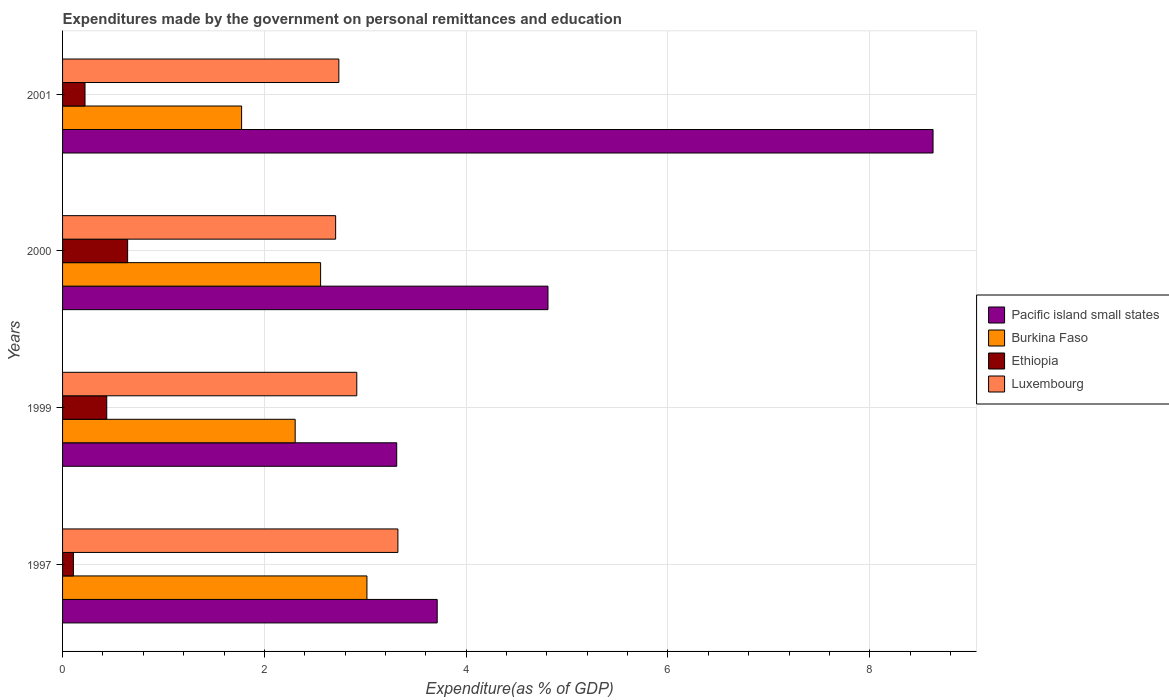How many bars are there on the 2nd tick from the top?
Your answer should be compact. 4. How many bars are there on the 1st tick from the bottom?
Ensure brevity in your answer.  4. In how many cases, is the number of bars for a given year not equal to the number of legend labels?
Your answer should be very brief. 0. What is the expenditures made by the government on personal remittances and education in Ethiopia in 2001?
Provide a short and direct response. 0.22. Across all years, what is the maximum expenditures made by the government on personal remittances and education in Burkina Faso?
Ensure brevity in your answer.  3.02. Across all years, what is the minimum expenditures made by the government on personal remittances and education in Pacific island small states?
Offer a very short reply. 3.31. What is the total expenditures made by the government on personal remittances and education in Luxembourg in the graph?
Your answer should be compact. 11.68. What is the difference between the expenditures made by the government on personal remittances and education in Pacific island small states in 1997 and that in 1999?
Provide a succinct answer. 0.4. What is the difference between the expenditures made by the government on personal remittances and education in Ethiopia in 1999 and the expenditures made by the government on personal remittances and education in Pacific island small states in 2001?
Give a very brief answer. -8.19. What is the average expenditures made by the government on personal remittances and education in Ethiopia per year?
Ensure brevity in your answer.  0.35. In the year 2000, what is the difference between the expenditures made by the government on personal remittances and education in Burkina Faso and expenditures made by the government on personal remittances and education in Luxembourg?
Your answer should be very brief. -0.15. What is the ratio of the expenditures made by the government on personal remittances and education in Burkina Faso in 1997 to that in 2000?
Keep it short and to the point. 1.18. What is the difference between the highest and the second highest expenditures made by the government on personal remittances and education in Pacific island small states?
Give a very brief answer. 3.82. What is the difference between the highest and the lowest expenditures made by the government on personal remittances and education in Burkina Faso?
Provide a short and direct response. 1.24. Is the sum of the expenditures made by the government on personal remittances and education in Luxembourg in 1997 and 1999 greater than the maximum expenditures made by the government on personal remittances and education in Burkina Faso across all years?
Make the answer very short. Yes. What does the 4th bar from the top in 1997 represents?
Offer a very short reply. Pacific island small states. What does the 4th bar from the bottom in 1999 represents?
Your answer should be compact. Luxembourg. How many bars are there?
Your answer should be compact. 16. Are all the bars in the graph horizontal?
Provide a short and direct response. Yes. How many years are there in the graph?
Offer a very short reply. 4. Where does the legend appear in the graph?
Offer a terse response. Center right. How many legend labels are there?
Provide a succinct answer. 4. What is the title of the graph?
Your response must be concise. Expenditures made by the government on personal remittances and education. What is the label or title of the X-axis?
Ensure brevity in your answer.  Expenditure(as % of GDP). What is the label or title of the Y-axis?
Keep it short and to the point. Years. What is the Expenditure(as % of GDP) in Pacific island small states in 1997?
Ensure brevity in your answer.  3.71. What is the Expenditure(as % of GDP) in Burkina Faso in 1997?
Keep it short and to the point. 3.02. What is the Expenditure(as % of GDP) in Ethiopia in 1997?
Your answer should be compact. 0.11. What is the Expenditure(as % of GDP) of Luxembourg in 1997?
Give a very brief answer. 3.32. What is the Expenditure(as % of GDP) in Pacific island small states in 1999?
Your answer should be very brief. 3.31. What is the Expenditure(as % of GDP) in Burkina Faso in 1999?
Make the answer very short. 2.31. What is the Expenditure(as % of GDP) in Ethiopia in 1999?
Your answer should be compact. 0.44. What is the Expenditure(as % of GDP) of Luxembourg in 1999?
Ensure brevity in your answer.  2.92. What is the Expenditure(as % of GDP) of Pacific island small states in 2000?
Offer a very short reply. 4.81. What is the Expenditure(as % of GDP) of Burkina Faso in 2000?
Your answer should be very brief. 2.56. What is the Expenditure(as % of GDP) of Ethiopia in 2000?
Give a very brief answer. 0.64. What is the Expenditure(as % of GDP) of Luxembourg in 2000?
Offer a very short reply. 2.71. What is the Expenditure(as % of GDP) in Pacific island small states in 2001?
Ensure brevity in your answer.  8.63. What is the Expenditure(as % of GDP) of Burkina Faso in 2001?
Make the answer very short. 1.77. What is the Expenditure(as % of GDP) of Ethiopia in 2001?
Your response must be concise. 0.22. What is the Expenditure(as % of GDP) of Luxembourg in 2001?
Provide a short and direct response. 2.74. Across all years, what is the maximum Expenditure(as % of GDP) of Pacific island small states?
Your answer should be compact. 8.63. Across all years, what is the maximum Expenditure(as % of GDP) in Burkina Faso?
Provide a short and direct response. 3.02. Across all years, what is the maximum Expenditure(as % of GDP) of Ethiopia?
Your answer should be compact. 0.64. Across all years, what is the maximum Expenditure(as % of GDP) of Luxembourg?
Provide a short and direct response. 3.32. Across all years, what is the minimum Expenditure(as % of GDP) of Pacific island small states?
Provide a succinct answer. 3.31. Across all years, what is the minimum Expenditure(as % of GDP) in Burkina Faso?
Ensure brevity in your answer.  1.77. Across all years, what is the minimum Expenditure(as % of GDP) in Ethiopia?
Your answer should be very brief. 0.11. Across all years, what is the minimum Expenditure(as % of GDP) in Luxembourg?
Offer a terse response. 2.71. What is the total Expenditure(as % of GDP) of Pacific island small states in the graph?
Provide a short and direct response. 20.46. What is the total Expenditure(as % of GDP) in Burkina Faso in the graph?
Provide a succinct answer. 9.65. What is the total Expenditure(as % of GDP) in Ethiopia in the graph?
Keep it short and to the point. 1.41. What is the total Expenditure(as % of GDP) of Luxembourg in the graph?
Keep it short and to the point. 11.68. What is the difference between the Expenditure(as % of GDP) in Pacific island small states in 1997 and that in 1999?
Offer a very short reply. 0.4. What is the difference between the Expenditure(as % of GDP) in Burkina Faso in 1997 and that in 1999?
Your answer should be very brief. 0.71. What is the difference between the Expenditure(as % of GDP) in Ethiopia in 1997 and that in 1999?
Give a very brief answer. -0.33. What is the difference between the Expenditure(as % of GDP) in Luxembourg in 1997 and that in 1999?
Offer a very short reply. 0.41. What is the difference between the Expenditure(as % of GDP) in Pacific island small states in 1997 and that in 2000?
Ensure brevity in your answer.  -1.1. What is the difference between the Expenditure(as % of GDP) in Burkina Faso in 1997 and that in 2000?
Offer a very short reply. 0.46. What is the difference between the Expenditure(as % of GDP) in Ethiopia in 1997 and that in 2000?
Provide a short and direct response. -0.54. What is the difference between the Expenditure(as % of GDP) of Luxembourg in 1997 and that in 2000?
Keep it short and to the point. 0.62. What is the difference between the Expenditure(as % of GDP) of Pacific island small states in 1997 and that in 2001?
Your response must be concise. -4.91. What is the difference between the Expenditure(as % of GDP) of Burkina Faso in 1997 and that in 2001?
Your answer should be very brief. 1.24. What is the difference between the Expenditure(as % of GDP) in Ethiopia in 1997 and that in 2001?
Your answer should be very brief. -0.12. What is the difference between the Expenditure(as % of GDP) in Luxembourg in 1997 and that in 2001?
Ensure brevity in your answer.  0.59. What is the difference between the Expenditure(as % of GDP) of Pacific island small states in 1999 and that in 2000?
Offer a very short reply. -1.5. What is the difference between the Expenditure(as % of GDP) of Burkina Faso in 1999 and that in 2000?
Your response must be concise. -0.25. What is the difference between the Expenditure(as % of GDP) in Ethiopia in 1999 and that in 2000?
Ensure brevity in your answer.  -0.21. What is the difference between the Expenditure(as % of GDP) of Luxembourg in 1999 and that in 2000?
Your response must be concise. 0.21. What is the difference between the Expenditure(as % of GDP) of Pacific island small states in 1999 and that in 2001?
Offer a terse response. -5.32. What is the difference between the Expenditure(as % of GDP) in Burkina Faso in 1999 and that in 2001?
Make the answer very short. 0.53. What is the difference between the Expenditure(as % of GDP) in Ethiopia in 1999 and that in 2001?
Ensure brevity in your answer.  0.22. What is the difference between the Expenditure(as % of GDP) of Luxembourg in 1999 and that in 2001?
Your response must be concise. 0.18. What is the difference between the Expenditure(as % of GDP) in Pacific island small states in 2000 and that in 2001?
Provide a succinct answer. -3.82. What is the difference between the Expenditure(as % of GDP) of Burkina Faso in 2000 and that in 2001?
Your answer should be compact. 0.78. What is the difference between the Expenditure(as % of GDP) of Ethiopia in 2000 and that in 2001?
Provide a short and direct response. 0.42. What is the difference between the Expenditure(as % of GDP) in Luxembourg in 2000 and that in 2001?
Your response must be concise. -0.03. What is the difference between the Expenditure(as % of GDP) of Pacific island small states in 1997 and the Expenditure(as % of GDP) of Burkina Faso in 1999?
Keep it short and to the point. 1.41. What is the difference between the Expenditure(as % of GDP) of Pacific island small states in 1997 and the Expenditure(as % of GDP) of Ethiopia in 1999?
Provide a succinct answer. 3.28. What is the difference between the Expenditure(as % of GDP) of Pacific island small states in 1997 and the Expenditure(as % of GDP) of Luxembourg in 1999?
Keep it short and to the point. 0.8. What is the difference between the Expenditure(as % of GDP) in Burkina Faso in 1997 and the Expenditure(as % of GDP) in Ethiopia in 1999?
Keep it short and to the point. 2.58. What is the difference between the Expenditure(as % of GDP) in Burkina Faso in 1997 and the Expenditure(as % of GDP) in Luxembourg in 1999?
Give a very brief answer. 0.1. What is the difference between the Expenditure(as % of GDP) of Ethiopia in 1997 and the Expenditure(as % of GDP) of Luxembourg in 1999?
Your answer should be very brief. -2.81. What is the difference between the Expenditure(as % of GDP) in Pacific island small states in 1997 and the Expenditure(as % of GDP) in Burkina Faso in 2000?
Make the answer very short. 1.16. What is the difference between the Expenditure(as % of GDP) in Pacific island small states in 1997 and the Expenditure(as % of GDP) in Ethiopia in 2000?
Your response must be concise. 3.07. What is the difference between the Expenditure(as % of GDP) in Pacific island small states in 1997 and the Expenditure(as % of GDP) in Luxembourg in 2000?
Keep it short and to the point. 1.01. What is the difference between the Expenditure(as % of GDP) in Burkina Faso in 1997 and the Expenditure(as % of GDP) in Ethiopia in 2000?
Provide a succinct answer. 2.37. What is the difference between the Expenditure(as % of GDP) in Burkina Faso in 1997 and the Expenditure(as % of GDP) in Luxembourg in 2000?
Your answer should be compact. 0.31. What is the difference between the Expenditure(as % of GDP) of Ethiopia in 1997 and the Expenditure(as % of GDP) of Luxembourg in 2000?
Ensure brevity in your answer.  -2.6. What is the difference between the Expenditure(as % of GDP) of Pacific island small states in 1997 and the Expenditure(as % of GDP) of Burkina Faso in 2001?
Your response must be concise. 1.94. What is the difference between the Expenditure(as % of GDP) of Pacific island small states in 1997 and the Expenditure(as % of GDP) of Ethiopia in 2001?
Give a very brief answer. 3.49. What is the difference between the Expenditure(as % of GDP) of Pacific island small states in 1997 and the Expenditure(as % of GDP) of Luxembourg in 2001?
Keep it short and to the point. 0.97. What is the difference between the Expenditure(as % of GDP) in Burkina Faso in 1997 and the Expenditure(as % of GDP) in Ethiopia in 2001?
Your answer should be very brief. 2.79. What is the difference between the Expenditure(as % of GDP) of Burkina Faso in 1997 and the Expenditure(as % of GDP) of Luxembourg in 2001?
Provide a short and direct response. 0.28. What is the difference between the Expenditure(as % of GDP) of Ethiopia in 1997 and the Expenditure(as % of GDP) of Luxembourg in 2001?
Offer a very short reply. -2.63. What is the difference between the Expenditure(as % of GDP) of Pacific island small states in 1999 and the Expenditure(as % of GDP) of Burkina Faso in 2000?
Provide a short and direct response. 0.75. What is the difference between the Expenditure(as % of GDP) of Pacific island small states in 1999 and the Expenditure(as % of GDP) of Ethiopia in 2000?
Offer a very short reply. 2.67. What is the difference between the Expenditure(as % of GDP) in Pacific island small states in 1999 and the Expenditure(as % of GDP) in Luxembourg in 2000?
Ensure brevity in your answer.  0.61. What is the difference between the Expenditure(as % of GDP) in Burkina Faso in 1999 and the Expenditure(as % of GDP) in Ethiopia in 2000?
Provide a succinct answer. 1.66. What is the difference between the Expenditure(as % of GDP) in Burkina Faso in 1999 and the Expenditure(as % of GDP) in Luxembourg in 2000?
Keep it short and to the point. -0.4. What is the difference between the Expenditure(as % of GDP) of Ethiopia in 1999 and the Expenditure(as % of GDP) of Luxembourg in 2000?
Keep it short and to the point. -2.27. What is the difference between the Expenditure(as % of GDP) of Pacific island small states in 1999 and the Expenditure(as % of GDP) of Burkina Faso in 2001?
Your response must be concise. 1.54. What is the difference between the Expenditure(as % of GDP) in Pacific island small states in 1999 and the Expenditure(as % of GDP) in Ethiopia in 2001?
Offer a terse response. 3.09. What is the difference between the Expenditure(as % of GDP) in Pacific island small states in 1999 and the Expenditure(as % of GDP) in Luxembourg in 2001?
Provide a succinct answer. 0.57. What is the difference between the Expenditure(as % of GDP) in Burkina Faso in 1999 and the Expenditure(as % of GDP) in Ethiopia in 2001?
Offer a very short reply. 2.08. What is the difference between the Expenditure(as % of GDP) in Burkina Faso in 1999 and the Expenditure(as % of GDP) in Luxembourg in 2001?
Provide a short and direct response. -0.43. What is the difference between the Expenditure(as % of GDP) of Ethiopia in 1999 and the Expenditure(as % of GDP) of Luxembourg in 2001?
Provide a succinct answer. -2.3. What is the difference between the Expenditure(as % of GDP) of Pacific island small states in 2000 and the Expenditure(as % of GDP) of Burkina Faso in 2001?
Your answer should be very brief. 3.04. What is the difference between the Expenditure(as % of GDP) of Pacific island small states in 2000 and the Expenditure(as % of GDP) of Ethiopia in 2001?
Your response must be concise. 4.59. What is the difference between the Expenditure(as % of GDP) in Pacific island small states in 2000 and the Expenditure(as % of GDP) in Luxembourg in 2001?
Your answer should be compact. 2.07. What is the difference between the Expenditure(as % of GDP) of Burkina Faso in 2000 and the Expenditure(as % of GDP) of Ethiopia in 2001?
Give a very brief answer. 2.34. What is the difference between the Expenditure(as % of GDP) of Burkina Faso in 2000 and the Expenditure(as % of GDP) of Luxembourg in 2001?
Make the answer very short. -0.18. What is the difference between the Expenditure(as % of GDP) of Ethiopia in 2000 and the Expenditure(as % of GDP) of Luxembourg in 2001?
Keep it short and to the point. -2.09. What is the average Expenditure(as % of GDP) in Pacific island small states per year?
Give a very brief answer. 5.12. What is the average Expenditure(as % of GDP) in Burkina Faso per year?
Keep it short and to the point. 2.41. What is the average Expenditure(as % of GDP) in Ethiopia per year?
Make the answer very short. 0.35. What is the average Expenditure(as % of GDP) in Luxembourg per year?
Keep it short and to the point. 2.92. In the year 1997, what is the difference between the Expenditure(as % of GDP) of Pacific island small states and Expenditure(as % of GDP) of Burkina Faso?
Provide a short and direct response. 0.7. In the year 1997, what is the difference between the Expenditure(as % of GDP) of Pacific island small states and Expenditure(as % of GDP) of Ethiopia?
Your answer should be very brief. 3.61. In the year 1997, what is the difference between the Expenditure(as % of GDP) in Pacific island small states and Expenditure(as % of GDP) in Luxembourg?
Give a very brief answer. 0.39. In the year 1997, what is the difference between the Expenditure(as % of GDP) of Burkina Faso and Expenditure(as % of GDP) of Ethiopia?
Your answer should be compact. 2.91. In the year 1997, what is the difference between the Expenditure(as % of GDP) of Burkina Faso and Expenditure(as % of GDP) of Luxembourg?
Offer a terse response. -0.31. In the year 1997, what is the difference between the Expenditure(as % of GDP) in Ethiopia and Expenditure(as % of GDP) in Luxembourg?
Keep it short and to the point. -3.22. In the year 1999, what is the difference between the Expenditure(as % of GDP) of Pacific island small states and Expenditure(as % of GDP) of Burkina Faso?
Give a very brief answer. 1.01. In the year 1999, what is the difference between the Expenditure(as % of GDP) in Pacific island small states and Expenditure(as % of GDP) in Ethiopia?
Ensure brevity in your answer.  2.87. In the year 1999, what is the difference between the Expenditure(as % of GDP) in Pacific island small states and Expenditure(as % of GDP) in Luxembourg?
Your answer should be compact. 0.4. In the year 1999, what is the difference between the Expenditure(as % of GDP) of Burkina Faso and Expenditure(as % of GDP) of Ethiopia?
Your answer should be very brief. 1.87. In the year 1999, what is the difference between the Expenditure(as % of GDP) of Burkina Faso and Expenditure(as % of GDP) of Luxembourg?
Your response must be concise. -0.61. In the year 1999, what is the difference between the Expenditure(as % of GDP) of Ethiopia and Expenditure(as % of GDP) of Luxembourg?
Give a very brief answer. -2.48. In the year 2000, what is the difference between the Expenditure(as % of GDP) of Pacific island small states and Expenditure(as % of GDP) of Burkina Faso?
Provide a short and direct response. 2.25. In the year 2000, what is the difference between the Expenditure(as % of GDP) in Pacific island small states and Expenditure(as % of GDP) in Ethiopia?
Give a very brief answer. 4.17. In the year 2000, what is the difference between the Expenditure(as % of GDP) in Pacific island small states and Expenditure(as % of GDP) in Luxembourg?
Offer a terse response. 2.1. In the year 2000, what is the difference between the Expenditure(as % of GDP) in Burkina Faso and Expenditure(as % of GDP) in Ethiopia?
Your answer should be very brief. 1.91. In the year 2000, what is the difference between the Expenditure(as % of GDP) in Burkina Faso and Expenditure(as % of GDP) in Luxembourg?
Provide a succinct answer. -0.15. In the year 2000, what is the difference between the Expenditure(as % of GDP) of Ethiopia and Expenditure(as % of GDP) of Luxembourg?
Your answer should be very brief. -2.06. In the year 2001, what is the difference between the Expenditure(as % of GDP) in Pacific island small states and Expenditure(as % of GDP) in Burkina Faso?
Offer a terse response. 6.85. In the year 2001, what is the difference between the Expenditure(as % of GDP) of Pacific island small states and Expenditure(as % of GDP) of Ethiopia?
Offer a very short reply. 8.41. In the year 2001, what is the difference between the Expenditure(as % of GDP) of Pacific island small states and Expenditure(as % of GDP) of Luxembourg?
Keep it short and to the point. 5.89. In the year 2001, what is the difference between the Expenditure(as % of GDP) of Burkina Faso and Expenditure(as % of GDP) of Ethiopia?
Give a very brief answer. 1.55. In the year 2001, what is the difference between the Expenditure(as % of GDP) of Burkina Faso and Expenditure(as % of GDP) of Luxembourg?
Keep it short and to the point. -0.96. In the year 2001, what is the difference between the Expenditure(as % of GDP) in Ethiopia and Expenditure(as % of GDP) in Luxembourg?
Offer a very short reply. -2.52. What is the ratio of the Expenditure(as % of GDP) of Pacific island small states in 1997 to that in 1999?
Ensure brevity in your answer.  1.12. What is the ratio of the Expenditure(as % of GDP) of Burkina Faso in 1997 to that in 1999?
Offer a very short reply. 1.31. What is the ratio of the Expenditure(as % of GDP) of Ethiopia in 1997 to that in 1999?
Keep it short and to the point. 0.25. What is the ratio of the Expenditure(as % of GDP) of Luxembourg in 1997 to that in 1999?
Offer a very short reply. 1.14. What is the ratio of the Expenditure(as % of GDP) of Pacific island small states in 1997 to that in 2000?
Keep it short and to the point. 0.77. What is the ratio of the Expenditure(as % of GDP) in Burkina Faso in 1997 to that in 2000?
Give a very brief answer. 1.18. What is the ratio of the Expenditure(as % of GDP) in Luxembourg in 1997 to that in 2000?
Make the answer very short. 1.23. What is the ratio of the Expenditure(as % of GDP) of Pacific island small states in 1997 to that in 2001?
Offer a terse response. 0.43. What is the ratio of the Expenditure(as % of GDP) in Ethiopia in 1997 to that in 2001?
Offer a terse response. 0.48. What is the ratio of the Expenditure(as % of GDP) of Luxembourg in 1997 to that in 2001?
Your answer should be very brief. 1.21. What is the ratio of the Expenditure(as % of GDP) of Pacific island small states in 1999 to that in 2000?
Keep it short and to the point. 0.69. What is the ratio of the Expenditure(as % of GDP) in Burkina Faso in 1999 to that in 2000?
Give a very brief answer. 0.9. What is the ratio of the Expenditure(as % of GDP) of Ethiopia in 1999 to that in 2000?
Keep it short and to the point. 0.68. What is the ratio of the Expenditure(as % of GDP) of Luxembourg in 1999 to that in 2000?
Ensure brevity in your answer.  1.08. What is the ratio of the Expenditure(as % of GDP) of Pacific island small states in 1999 to that in 2001?
Ensure brevity in your answer.  0.38. What is the ratio of the Expenditure(as % of GDP) of Burkina Faso in 1999 to that in 2001?
Your answer should be very brief. 1.3. What is the ratio of the Expenditure(as % of GDP) in Ethiopia in 1999 to that in 2001?
Offer a terse response. 1.97. What is the ratio of the Expenditure(as % of GDP) of Luxembourg in 1999 to that in 2001?
Give a very brief answer. 1.06. What is the ratio of the Expenditure(as % of GDP) of Pacific island small states in 2000 to that in 2001?
Your answer should be very brief. 0.56. What is the ratio of the Expenditure(as % of GDP) of Burkina Faso in 2000 to that in 2001?
Keep it short and to the point. 1.44. What is the ratio of the Expenditure(as % of GDP) of Ethiopia in 2000 to that in 2001?
Offer a terse response. 2.9. What is the ratio of the Expenditure(as % of GDP) in Luxembourg in 2000 to that in 2001?
Ensure brevity in your answer.  0.99. What is the difference between the highest and the second highest Expenditure(as % of GDP) in Pacific island small states?
Your answer should be compact. 3.82. What is the difference between the highest and the second highest Expenditure(as % of GDP) of Burkina Faso?
Offer a very short reply. 0.46. What is the difference between the highest and the second highest Expenditure(as % of GDP) of Ethiopia?
Provide a short and direct response. 0.21. What is the difference between the highest and the second highest Expenditure(as % of GDP) of Luxembourg?
Your answer should be very brief. 0.41. What is the difference between the highest and the lowest Expenditure(as % of GDP) in Pacific island small states?
Give a very brief answer. 5.32. What is the difference between the highest and the lowest Expenditure(as % of GDP) in Burkina Faso?
Ensure brevity in your answer.  1.24. What is the difference between the highest and the lowest Expenditure(as % of GDP) of Ethiopia?
Make the answer very short. 0.54. What is the difference between the highest and the lowest Expenditure(as % of GDP) in Luxembourg?
Make the answer very short. 0.62. 